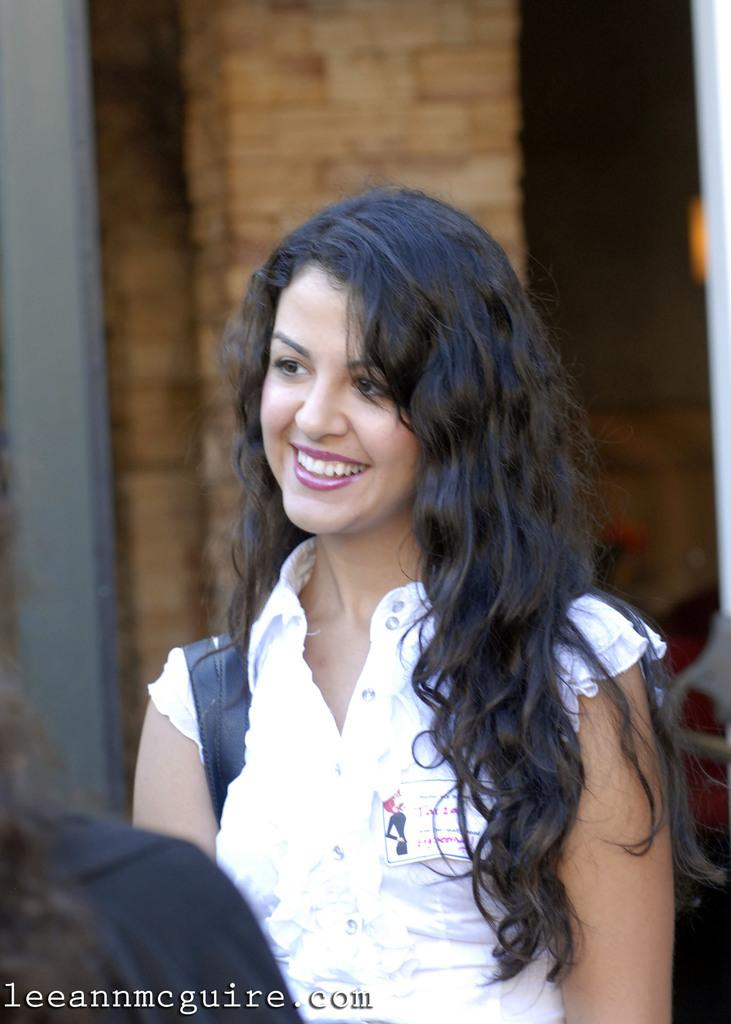Who is present in the image? There is a woman in the image. What can be seen in the background of the image? There is a wall in the background of the image. What is the intensity of the alarm in the image? There is no alarm present in the image. How does the rainstorm affect the woman in the image? There is no rainstorm present in the image; it only features a woman and a wall in the background. 